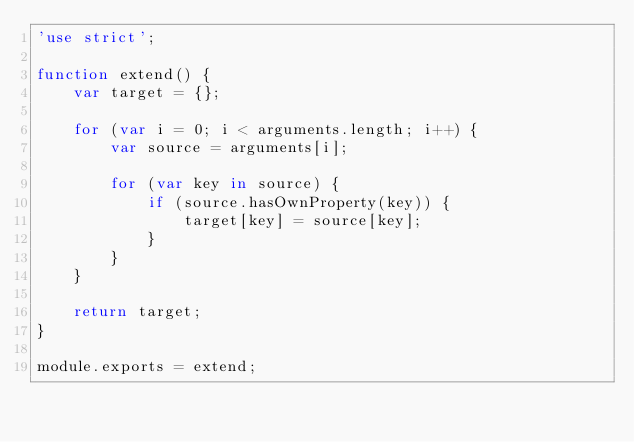Convert code to text. <code><loc_0><loc_0><loc_500><loc_500><_JavaScript_>'use strict';

function extend() {
    var target = {};

    for (var i = 0; i < arguments.length; i++) {
        var source = arguments[i];

        for (var key in source) {
            if (source.hasOwnProperty(key)) {
                target[key] = source[key];
            }
        }
    }

    return target;
}

module.exports = extend;
</code> 